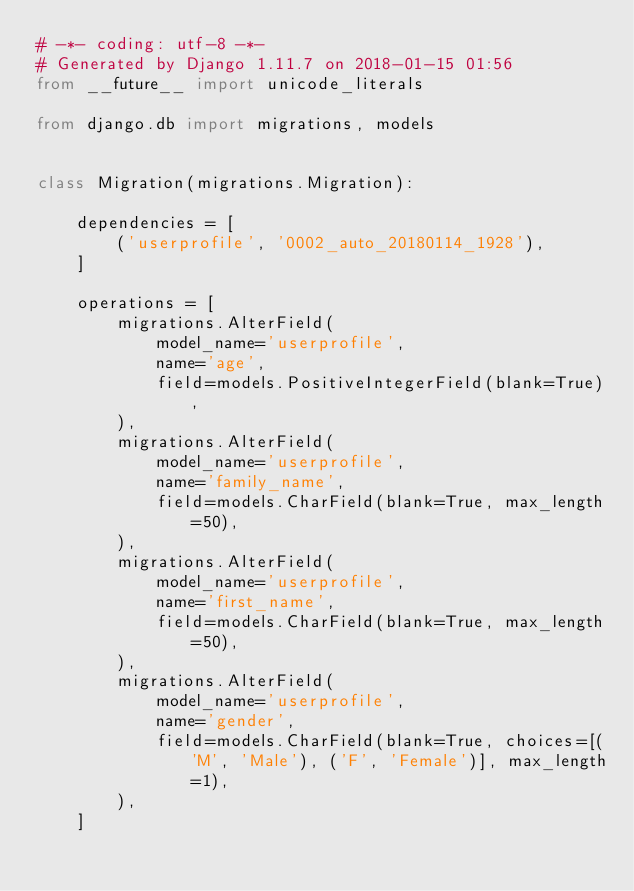Convert code to text. <code><loc_0><loc_0><loc_500><loc_500><_Python_># -*- coding: utf-8 -*-
# Generated by Django 1.11.7 on 2018-01-15 01:56
from __future__ import unicode_literals

from django.db import migrations, models


class Migration(migrations.Migration):

    dependencies = [
        ('userprofile', '0002_auto_20180114_1928'),
    ]

    operations = [
        migrations.AlterField(
            model_name='userprofile',
            name='age',
            field=models.PositiveIntegerField(blank=True),
        ),
        migrations.AlterField(
            model_name='userprofile',
            name='family_name',
            field=models.CharField(blank=True, max_length=50),
        ),
        migrations.AlterField(
            model_name='userprofile',
            name='first_name',
            field=models.CharField(blank=True, max_length=50),
        ),
        migrations.AlterField(
            model_name='userprofile',
            name='gender',
            field=models.CharField(blank=True, choices=[('M', 'Male'), ('F', 'Female')], max_length=1),
        ),
    ]
</code> 